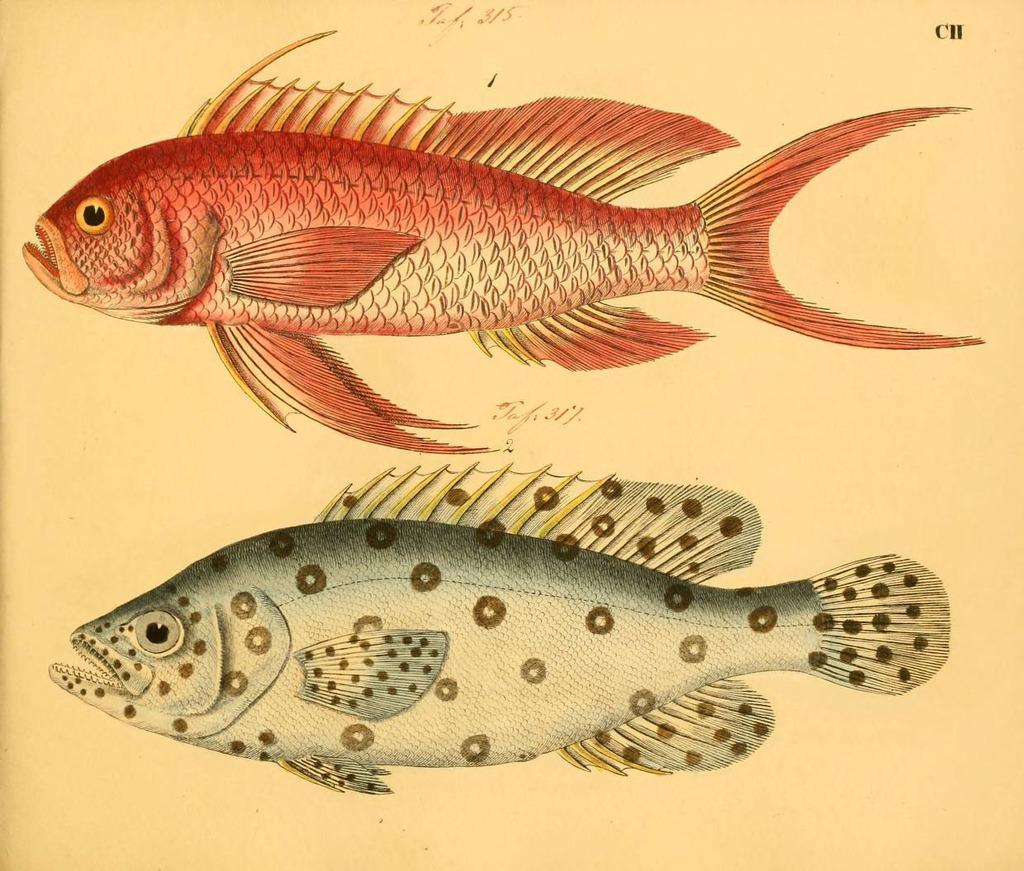Describe this image in one or two sentences. In this picture we can see a painted paper, on which we can see fishes. 